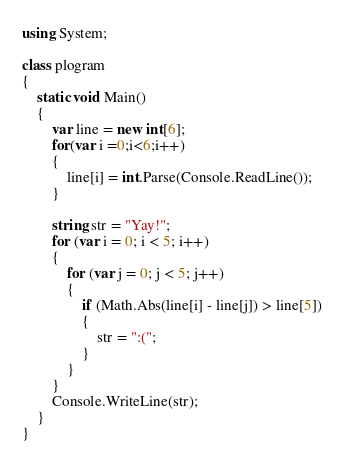Convert code to text. <code><loc_0><loc_0><loc_500><loc_500><_C#_>using System;

class plogram
{
    static void Main()
    {
        var line = new int[6];
        for(var i =0;i<6;i++)
        {
            line[i] = int.Parse(Console.ReadLine());
        }

        string str = "Yay!";
        for (var i = 0; i < 5; i++)
        {
            for (var j = 0; j < 5; j++)
            {
                if (Math.Abs(line[i] - line[j]) > line[5])
                {
                    str = ":(";
                }
            }
        }
        Console.WriteLine(str);
    }
}
</code> 